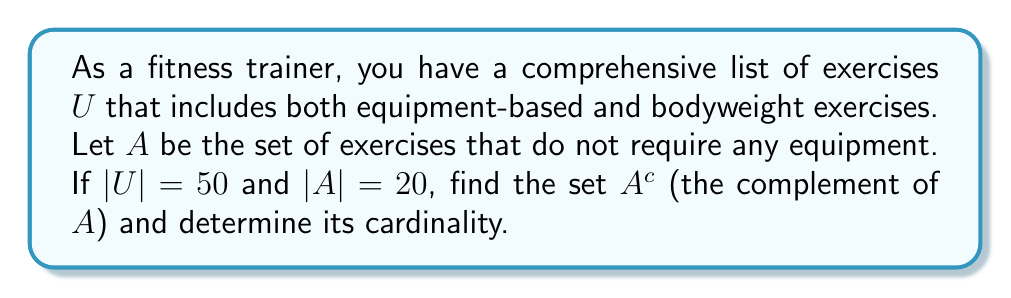What is the answer to this math problem? To solve this problem, let's follow these steps:

1) First, let's define our sets:
   $U$ = Universal set of all exercises
   $A$ = Set of exercises that do not require equipment
   $A^c$ = Complement of set $A$

2) We're given that:
   $|U| = 50$ (total number of exercises)
   $|A| = 20$ (number of exercises not requiring equipment)

3) The complement of a set $A$ ($A^c$) is defined as all elements in the universal set $U$ that are not in $A$. In this context, $A^c$ represents all exercises that do require equipment.

4) To find $A^c$, we can use the formula:
   $A^c = U - A$

5) The cardinality of $A^c$ can be calculated using:
   $|A^c| = |U| - |A|$

6) Substituting the given values:
   $|A^c| = 50 - 20 = 30$

Therefore, $A^c$ contains 30 exercises, which are all the exercises in the universal set that do require equipment.
Answer: $A^c$ is the set of exercises that require equipment, and $|A^c| = 30$ 